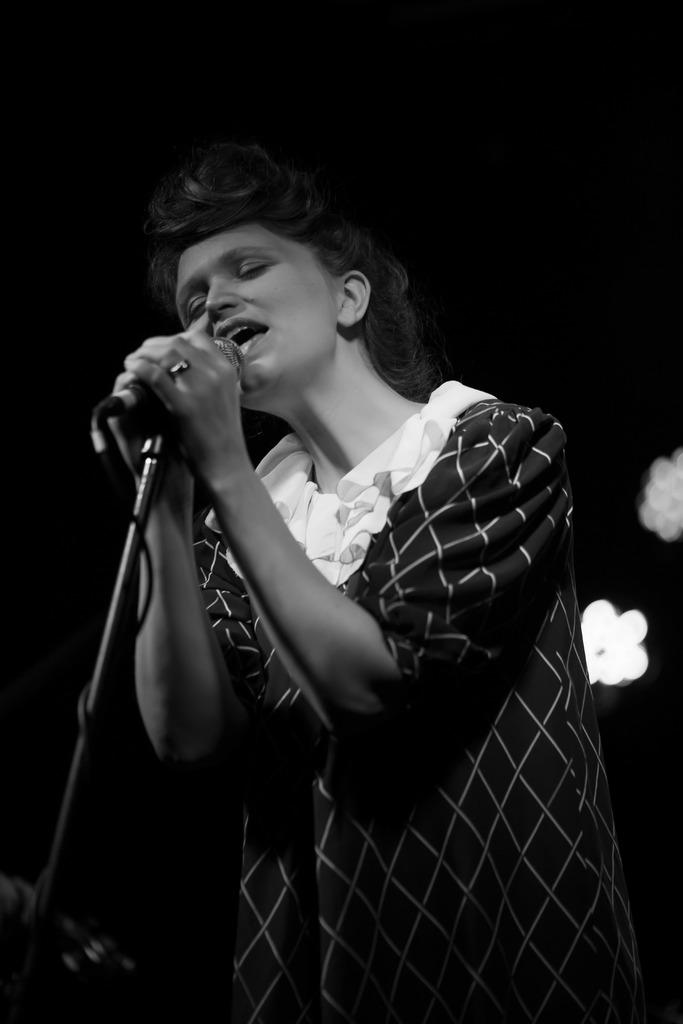What is the color scheme of the image? The image is black and white. Who is the main subject in the image? There is a woman in the middle of the image. What is the woman doing in the image? The woman is singing on a microphone. What can be seen in the background of the image? There are lights visible in the background. What is the woman's sister's theory about the zephyr in the image? A: There is no mention of a sister or a zephyr in the image, so we cannot determine any theories about them. 